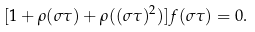<formula> <loc_0><loc_0><loc_500><loc_500>[ 1 + \rho ( \sigma \tau ) + \rho ( ( \sigma \tau ) ^ { 2 } ) ] f ( \sigma \tau ) = 0 .</formula> 